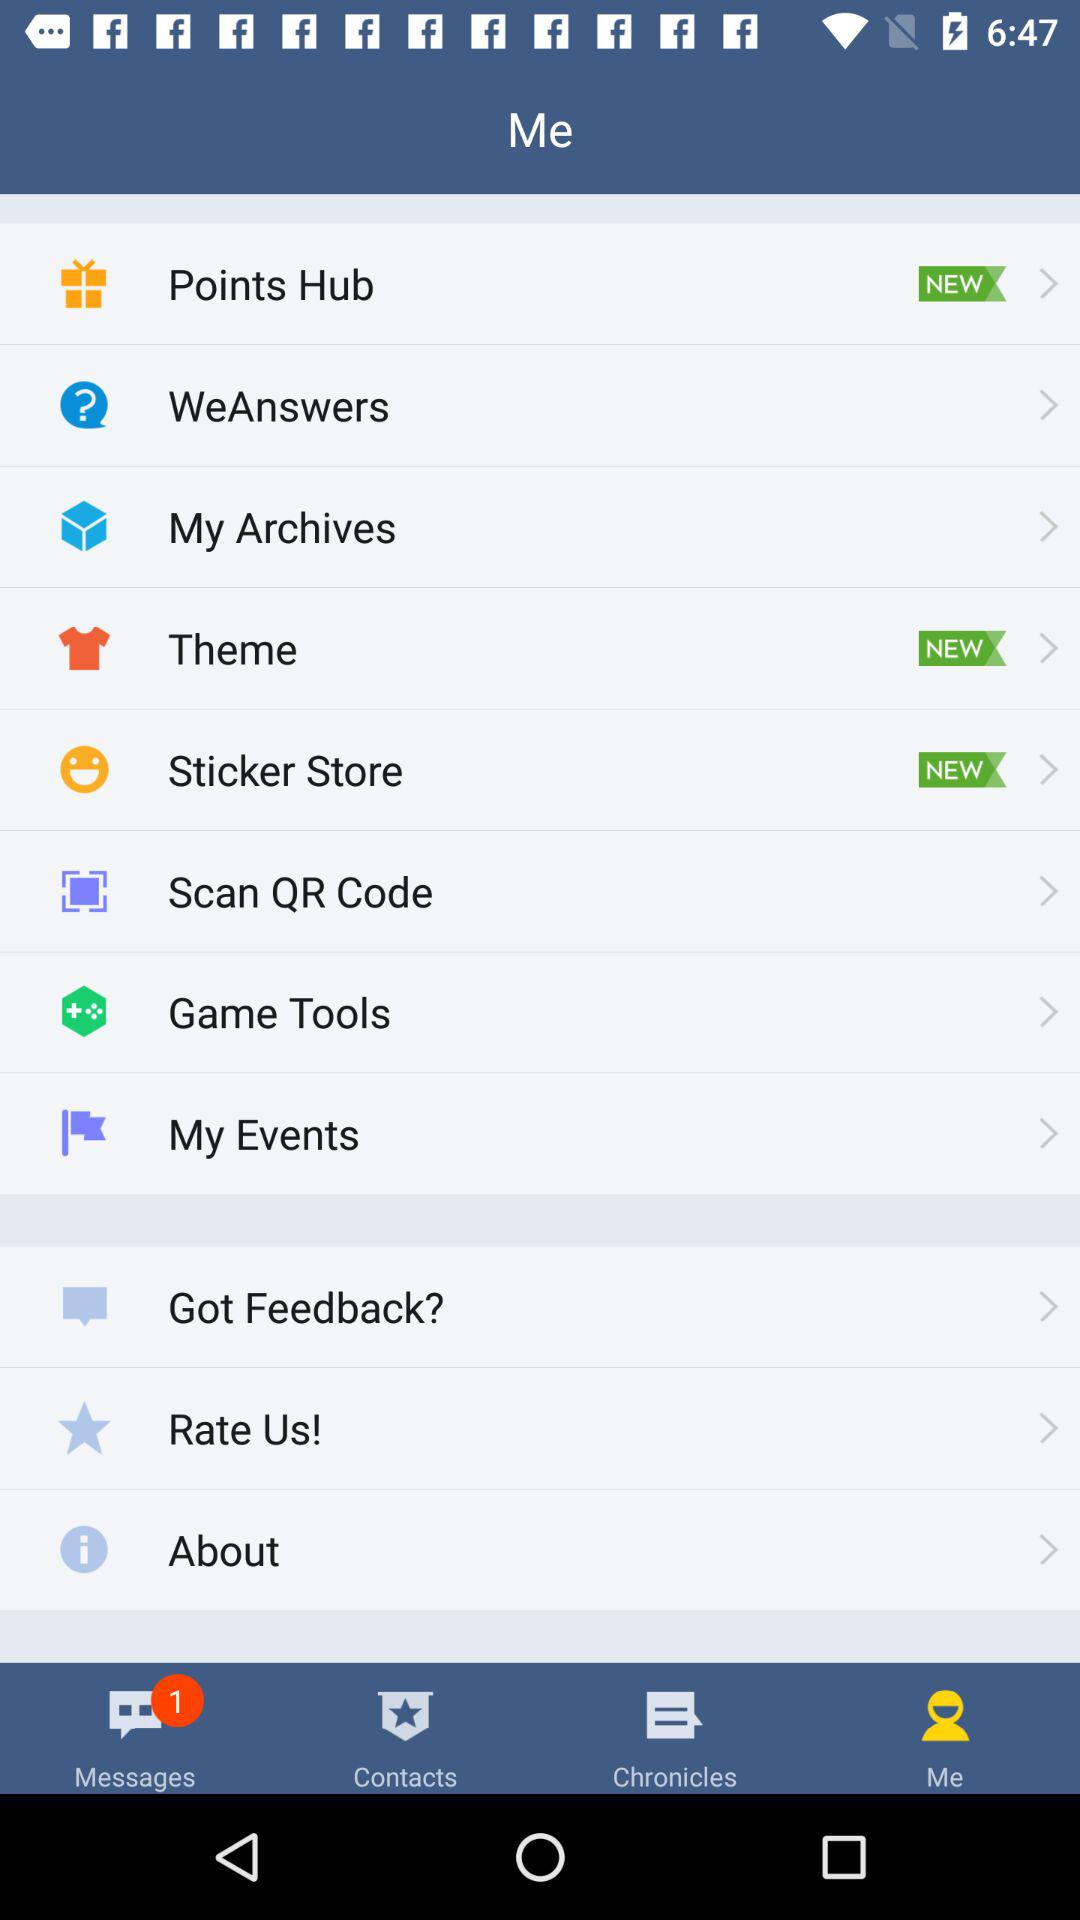How many unread messages are there? There is 1 unread message. 